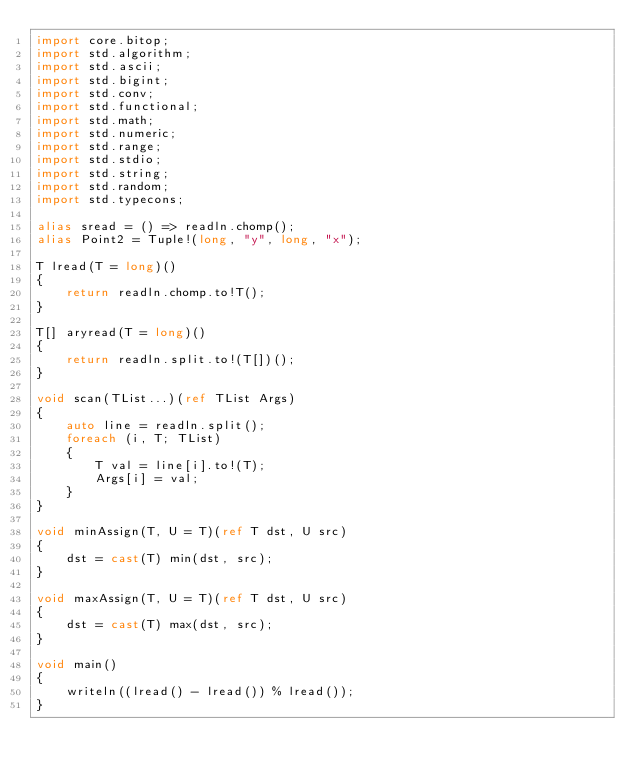<code> <loc_0><loc_0><loc_500><loc_500><_D_>import core.bitop;
import std.algorithm;
import std.ascii;
import std.bigint;
import std.conv;
import std.functional;
import std.math;
import std.numeric;
import std.range;
import std.stdio;
import std.string;
import std.random;
import std.typecons;

alias sread = () => readln.chomp();
alias Point2 = Tuple!(long, "y", long, "x");

T lread(T = long)()
{
    return readln.chomp.to!T();
}

T[] aryread(T = long)()
{
    return readln.split.to!(T[])();
}

void scan(TList...)(ref TList Args)
{
    auto line = readln.split();
    foreach (i, T; TList)
    {
        T val = line[i].to!(T);
        Args[i] = val;
    }
}

void minAssign(T, U = T)(ref T dst, U src)
{
    dst = cast(T) min(dst, src);
}

void maxAssign(T, U = T)(ref T dst, U src)
{
    dst = cast(T) max(dst, src);
}

void main()
{
    writeln((lread() - lread()) % lread());
}
</code> 